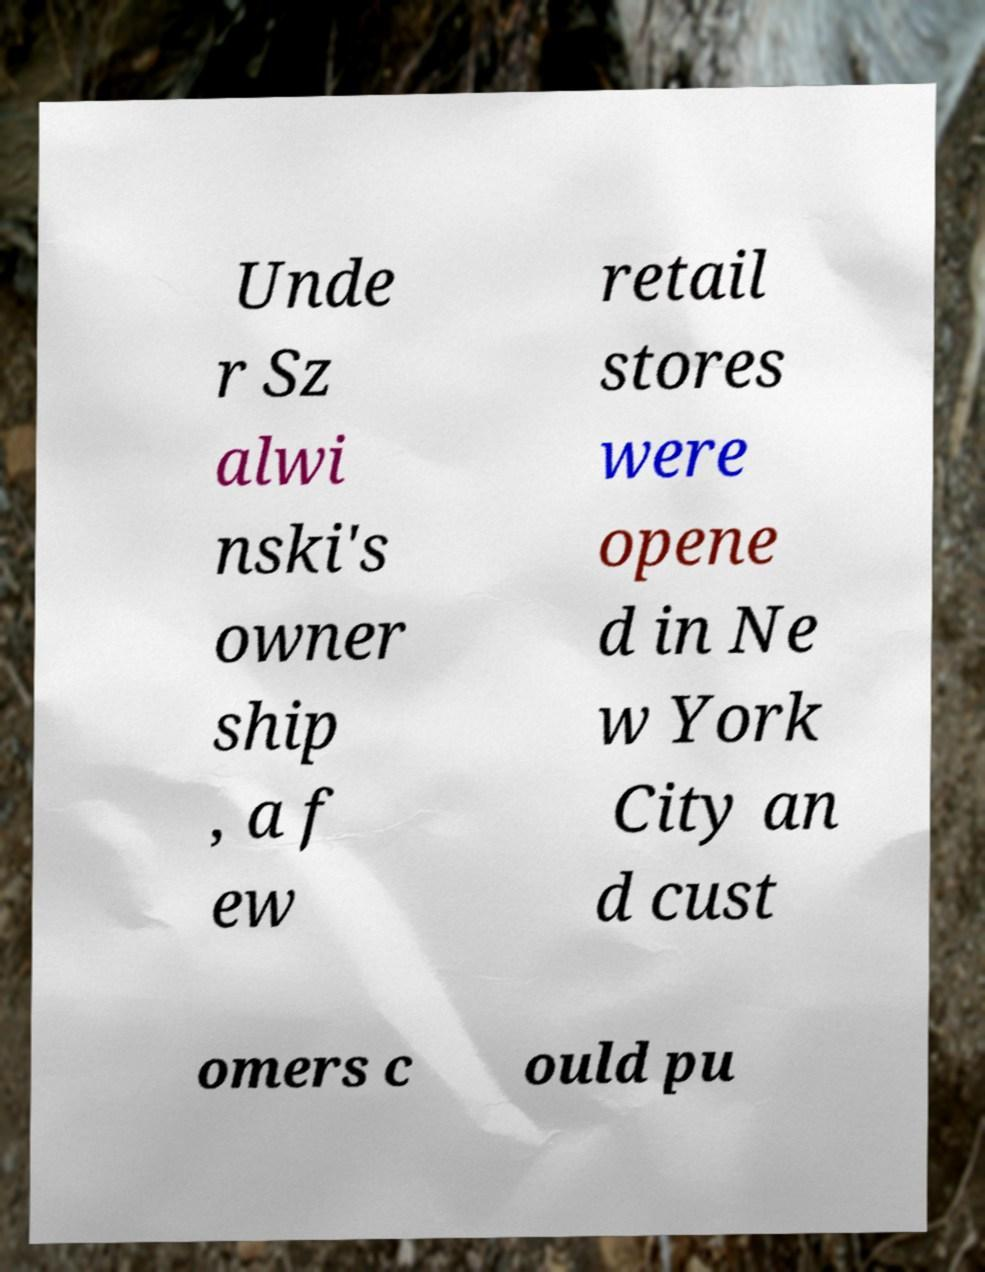Can you read and provide the text displayed in the image?This photo seems to have some interesting text. Can you extract and type it out for me? Unde r Sz alwi nski's owner ship , a f ew retail stores were opene d in Ne w York City an d cust omers c ould pu 